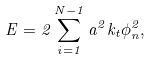<formula> <loc_0><loc_0><loc_500><loc_500>E = 2 \sum _ { i = 1 } ^ { N - 1 } a ^ { 2 } k _ { t } \phi _ { n } ^ { 2 } ,</formula> 